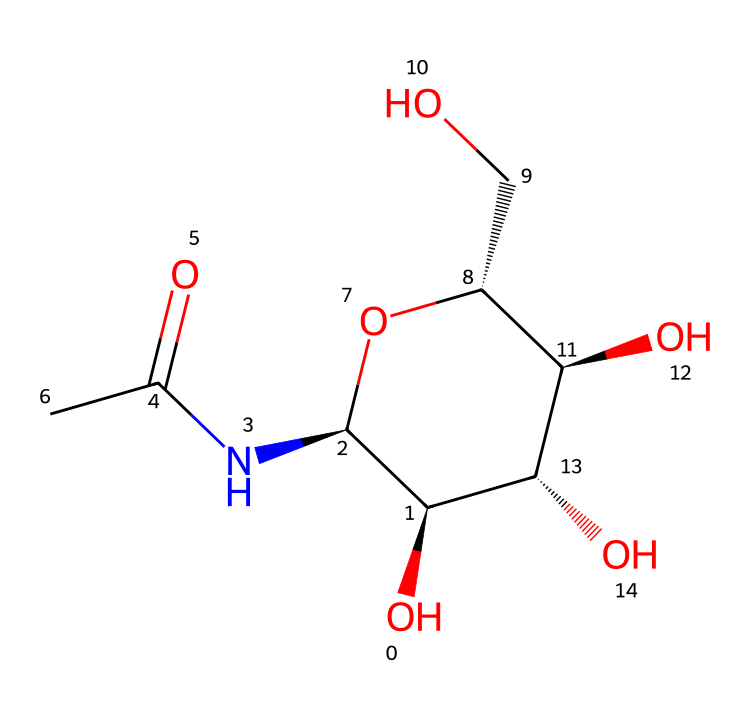What is the name of this carbohydrate? The provided SMILES code represents chitin, which is a long-chain polysaccharide made of N-acetylglucosamine units. This polysaccharide is a key component of the exoskeletons of insects.
Answer: chitin How many carbon atoms are in this structure? By analyzing the SMILES representation and counting the 'C' atoms, one can identify there are 8 carbon atoms present in the structure.
Answer: 8 What type of glycosidic bond is present in chitin? Chitin contains beta-1,4-glycosidic bonds, linking the N-acetylglucosamine units together. This type of bond is characteristic of chitin and other similar carbohydrates.
Answer: beta-1,4 How many nitrogen atoms are in this molecule? Upon examining the SMILES notation for nitrogen ('N'), we find there is one nitrogen atom. This nitrogen is part of the N-acetyl group in the N-acetylglucosamine monomer.
Answer: 1 What functional group is present that contributes to the structural strength of this carbohydrate? The functional group contributing to the structural strength of chitin is the amide group (C=O and N-H), which is part of the N-acetyl group. This contributes to hydrogen bonding and strength in the exoskeleton structure.
Answer: amide group How many hydroxyl (OH) groups are present in this structure? By inspecting the structure, we observe there are 3 hydroxyl (-OH) groups located on the sugar units, which are crucial for the solubility and reactivity of chitin.
Answer: 3 What is the role of chitin in insect exoskeletons? Chitin serves as a tough, protective material that forms the exoskeleton of insects, providing structural support and protection from environmental factors.
Answer: protective material 